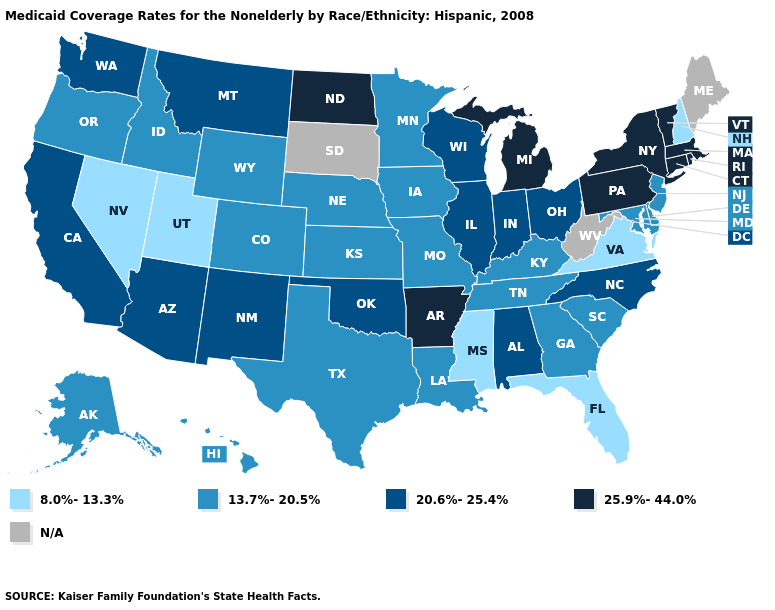Name the states that have a value in the range 13.7%-20.5%?
Be succinct. Alaska, Colorado, Delaware, Georgia, Hawaii, Idaho, Iowa, Kansas, Kentucky, Louisiana, Maryland, Minnesota, Missouri, Nebraska, New Jersey, Oregon, South Carolina, Tennessee, Texas, Wyoming. What is the lowest value in states that border Michigan?
Write a very short answer. 20.6%-25.4%. What is the value of Virginia?
Quick response, please. 8.0%-13.3%. What is the value of Alaska?
Short answer required. 13.7%-20.5%. What is the lowest value in the Northeast?
Give a very brief answer. 8.0%-13.3%. Does the first symbol in the legend represent the smallest category?
Write a very short answer. Yes. What is the lowest value in states that border Georgia?
Quick response, please. 8.0%-13.3%. Which states have the lowest value in the MidWest?
Give a very brief answer. Iowa, Kansas, Minnesota, Missouri, Nebraska. How many symbols are there in the legend?
Quick response, please. 5. Is the legend a continuous bar?
Write a very short answer. No. Is the legend a continuous bar?
Concise answer only. No. Name the states that have a value in the range N/A?
Quick response, please. Maine, South Dakota, West Virginia. What is the value of Missouri?
Give a very brief answer. 13.7%-20.5%. Name the states that have a value in the range 8.0%-13.3%?
Give a very brief answer. Florida, Mississippi, Nevada, New Hampshire, Utah, Virginia. 